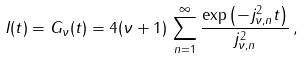Convert formula to latex. <formula><loc_0><loc_0><loc_500><loc_500>I ( t ) = G _ { \nu } ( t ) = 4 ( \nu + 1 ) \, \sum _ { n = 1 } ^ { \infty } \frac { \exp \left ( - j _ { \nu , n } ^ { 2 } t \right ) } { j _ { \nu , n } ^ { 2 } } \, ,</formula> 